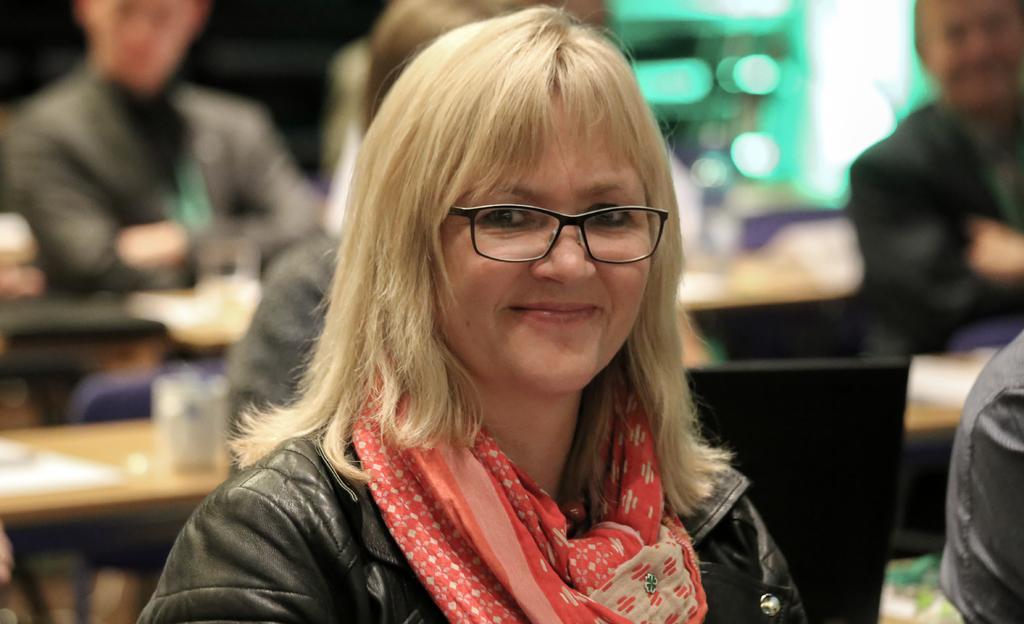How would you summarize this image in a sentence or two? There is a woman smiling and wore spectacle. In the background it is blurry and we can see people and objects on tables. 